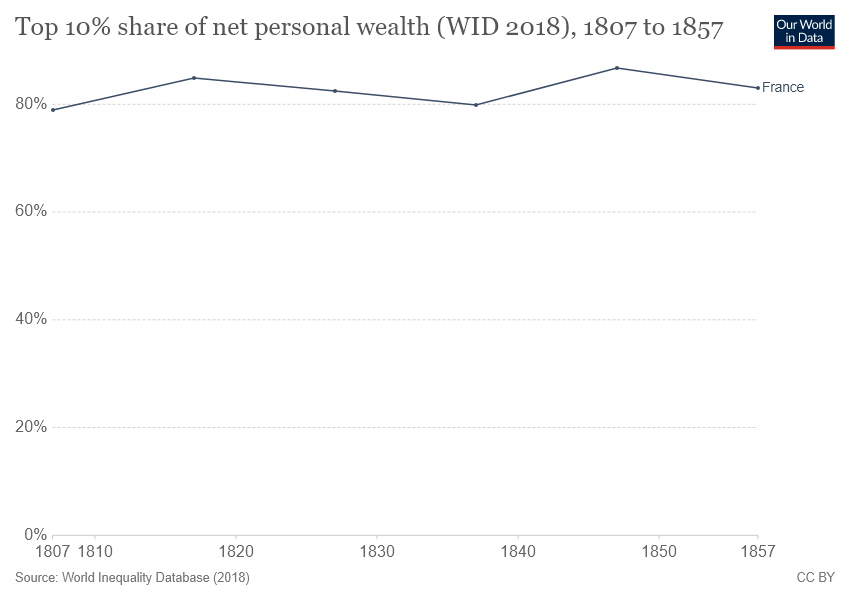Mention a couple of crucial points in this snapshot. For how many years has the temperature been below 80%? The chart displays data about a country that is France. 